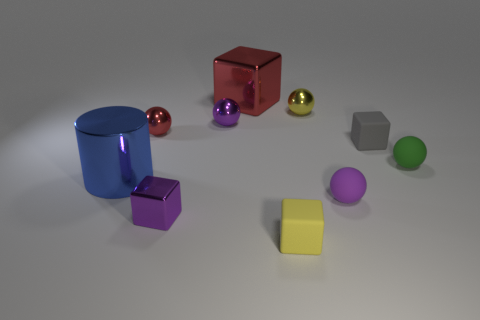What is the material of the tiny yellow thing that is the same shape as the small red thing? The tiny yellow thing that shares its shape with the small red object appears to be made of plastic, which is a common material for objects of this type in various colors. 